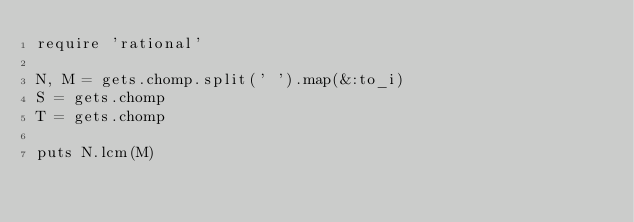Convert code to text. <code><loc_0><loc_0><loc_500><loc_500><_Ruby_>require 'rational'

N, M = gets.chomp.split(' ').map(&:to_i)
S = gets.chomp
T = gets.chomp

puts N.lcm(M)</code> 